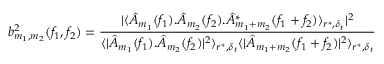<formula> <loc_0><loc_0><loc_500><loc_500>b _ { m _ { 1 } , m _ { 2 } } ^ { 2 } ( f _ { 1 } , f _ { 2 } ) = \frac { | \langle \hat { A } _ { m _ { 1 } } ( f _ { 1 } ) . \hat { A } _ { m _ { 2 } } ( f _ { 2 } ) . \hat { A } _ { m _ { 1 } + m _ { 2 } } ^ { * } ( f _ { 1 } + f _ { 2 } ) \rangle _ { r ^ { * } , \delta _ { t } } | ^ { 2 } } { \langle | \hat { A } _ { m _ { 1 } } ( f _ { 1 } ) . \hat { A } _ { m _ { 2 } } ( f _ { 2 } ) | ^ { 2 } \rangle _ { r ^ { * } , \delta _ { t } } \langle | \hat { A } _ { m _ { 1 } + m _ { 2 } } ( f _ { 1 } + f _ { 2 } ) | ^ { 2 } \rangle _ { r ^ { * } , \delta _ { t } } }</formula> 